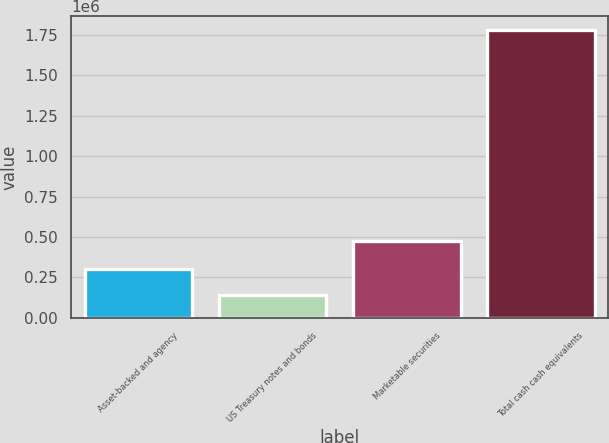<chart> <loc_0><loc_0><loc_500><loc_500><bar_chart><fcel>Asset-backed and agency<fcel>US Treasury notes and bonds<fcel>Marketable securities<fcel>Total cash cash equivalents<nl><fcel>304575<fcel>140728<fcel>476599<fcel>1.7792e+06<nl></chart> 